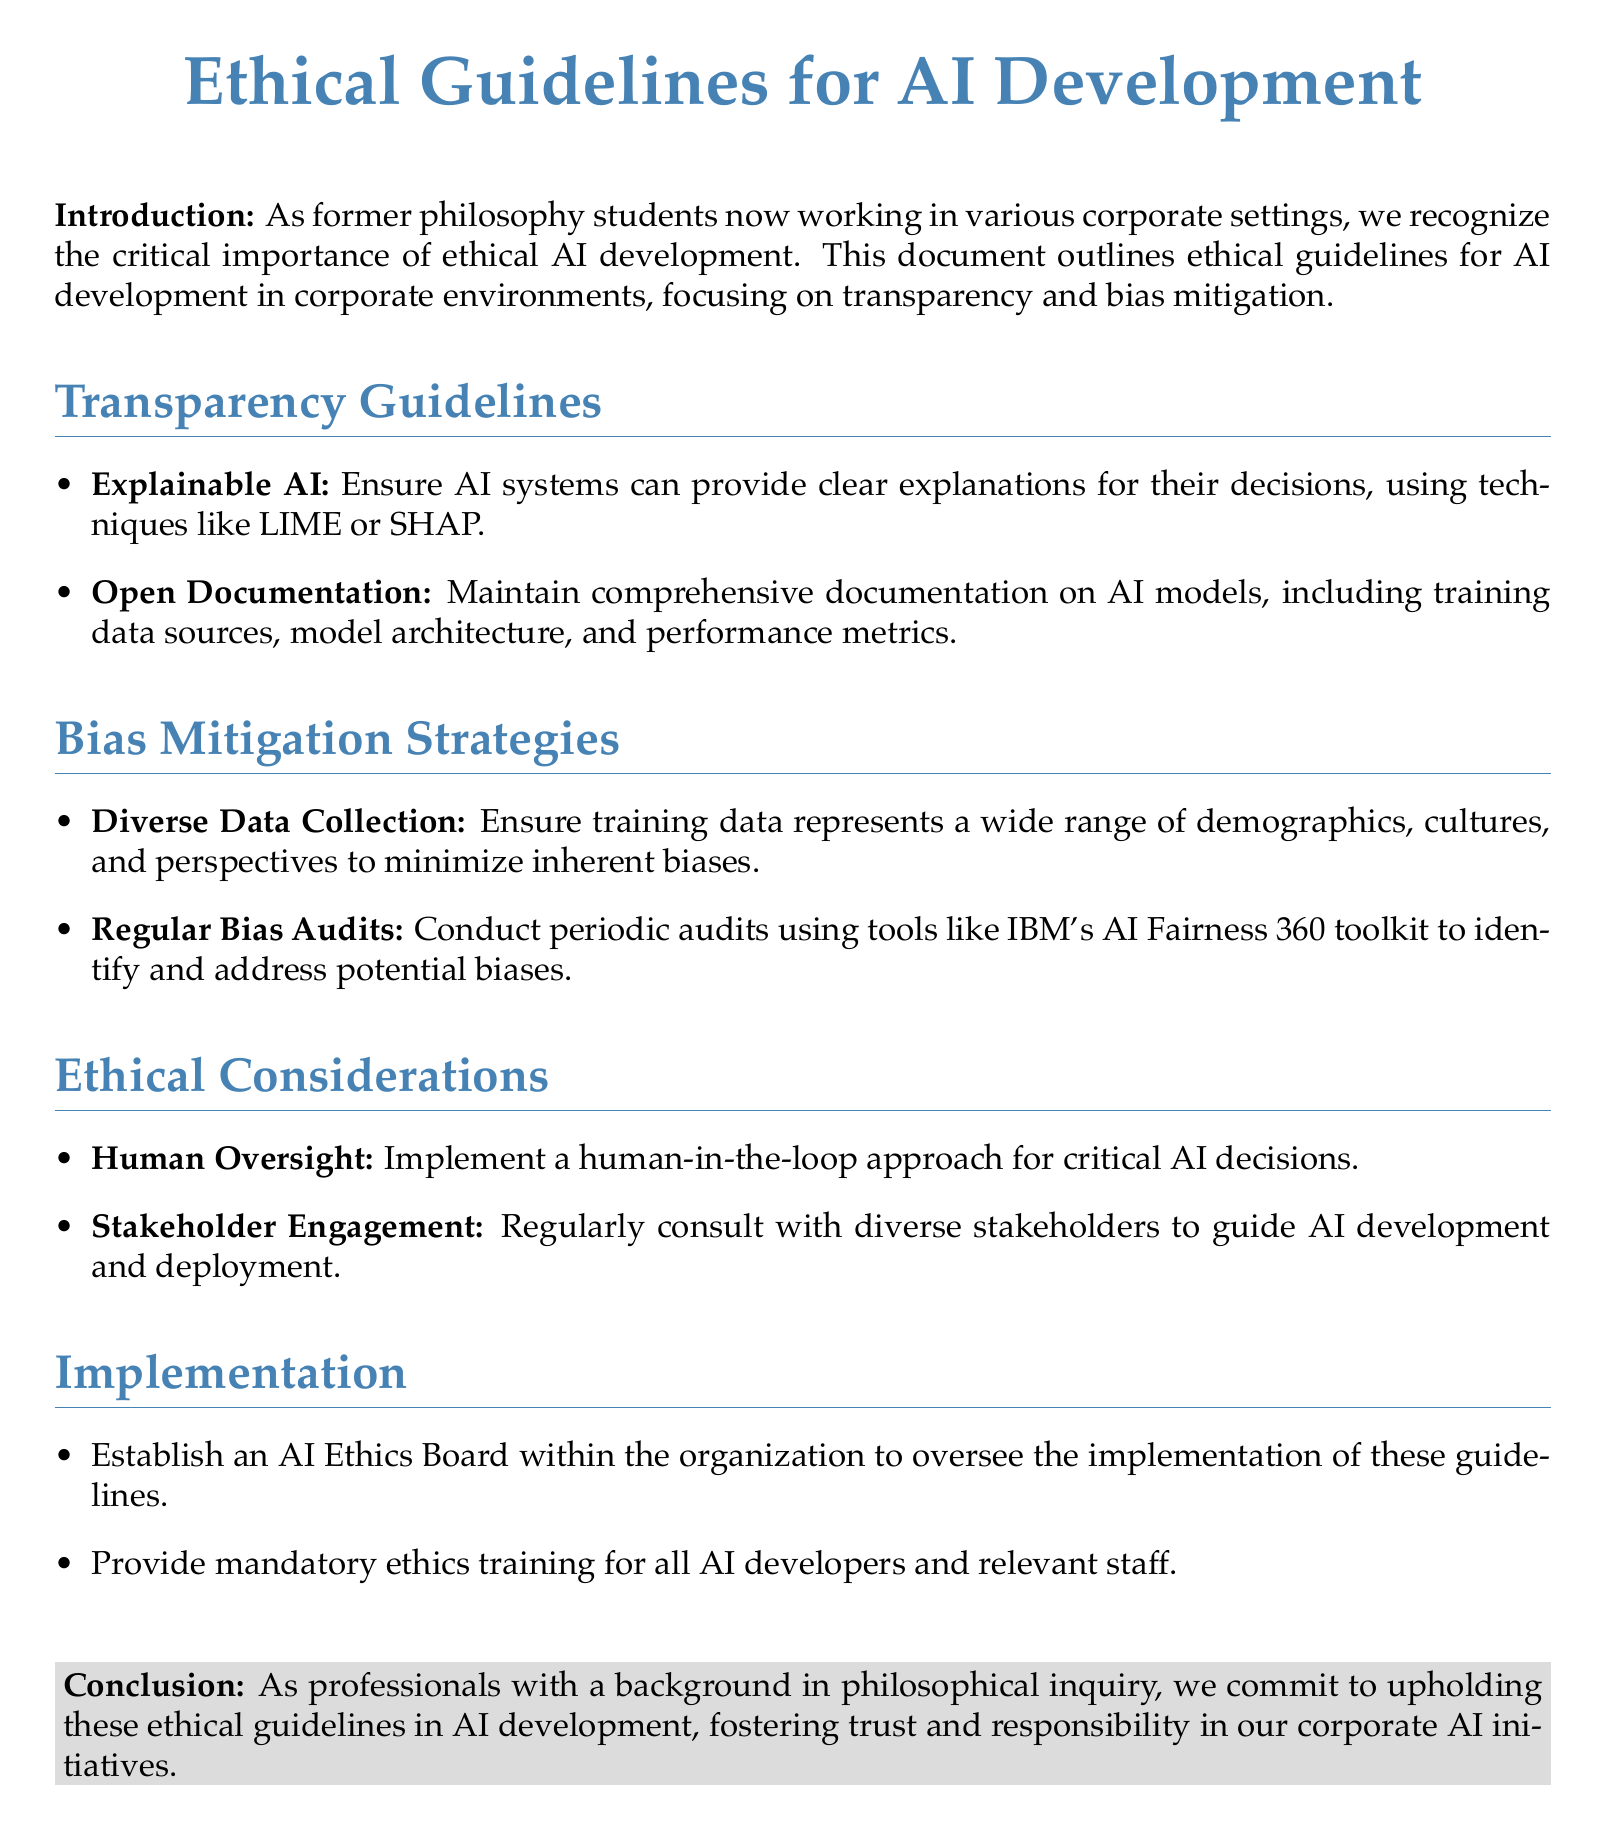What is the main focus of the guidelines? The guidelines primarily focus on ethical AI development, emphasizing transparency and bias mitigation.
Answer: ethical AI development What is one method mentioned for explainable AI? The document mentions using techniques like LIME or SHAP for clear explanations of AI decisions.
Answer: LIME or SHAP What should be maintained according to the open documentation guideline? The guideline suggests maintaining comprehensive documentation that includes training data sources, model architecture, and performance metrics.
Answer: comprehensive documentation How often should bias audits be conducted? The document specifies that bias audits should be conducted periodically.
Answer: periodically What role does the AI Ethics Board serve? The AI Ethics Board is established to oversee the implementation of the ethical guidelines within the organization.
Answer: oversee implementation What approach is recommended for critical AI decisions? A human-in-the-loop approach is recommended for critical AI decisions.
Answer: human-in-the-loop Which toolkit is suggested for conducting regular bias audits? The IBM's AI Fairness 360 toolkit is suggested for this purpose.
Answer: IBM's AI Fairness 360 toolkit What is a key action for stakeholder engagement? The document emphasizes regularly consulting with diverse stakeholders to guide AI development.
Answer: regularly consulting What type of training is mandatory for AI developers? The document states that mandatory ethics training should be provided for all AI developers and relevant staff.
Answer: ethics training 